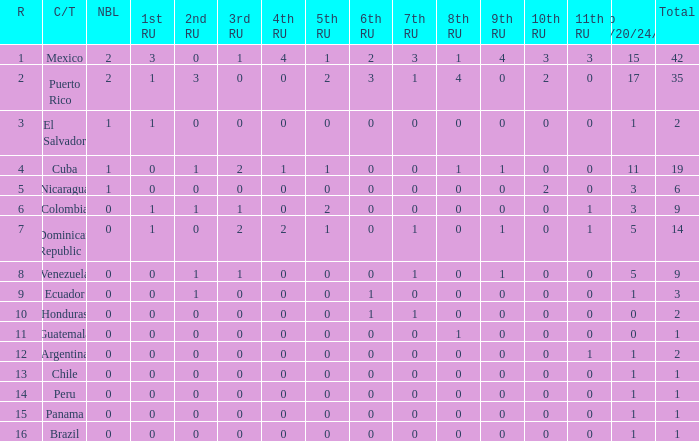What is the 9th runner-up with a top 18/20/24/30 greater than 17 and a 5th runner-up of 2? None. 